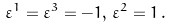<formula> <loc_0><loc_0><loc_500><loc_500>\varepsilon ^ { 1 } = \varepsilon ^ { 3 } = - 1 , \, \varepsilon ^ { 2 } = 1 \, .</formula> 